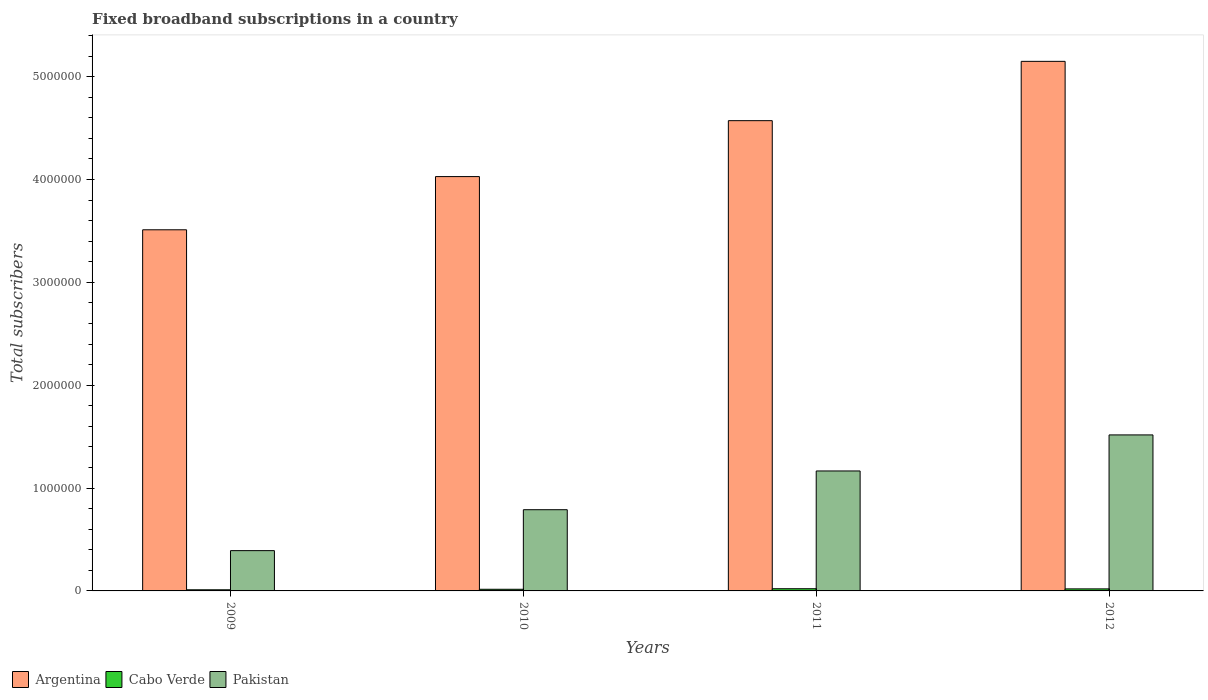In how many cases, is the number of bars for a given year not equal to the number of legend labels?
Offer a very short reply. 0. What is the number of broadband subscriptions in Pakistan in 2010?
Your answer should be compact. 7.89e+05. Across all years, what is the maximum number of broadband subscriptions in Pakistan?
Provide a succinct answer. 1.52e+06. Across all years, what is the minimum number of broadband subscriptions in Cabo Verde?
Provide a short and direct response. 1.10e+04. What is the total number of broadband subscriptions in Pakistan in the graph?
Ensure brevity in your answer.  3.86e+06. What is the difference between the number of broadband subscriptions in Cabo Verde in 2009 and that in 2012?
Keep it short and to the point. -8881. What is the difference between the number of broadband subscriptions in Argentina in 2010 and the number of broadband subscriptions in Pakistan in 2012?
Make the answer very short. 2.51e+06. What is the average number of broadband subscriptions in Pakistan per year?
Your response must be concise. 9.66e+05. In the year 2009, what is the difference between the number of broadband subscriptions in Argentina and number of broadband subscriptions in Pakistan?
Your answer should be very brief. 3.12e+06. What is the ratio of the number of broadband subscriptions in Cabo Verde in 2009 to that in 2010?
Give a very brief answer. 0.68. Is the number of broadband subscriptions in Argentina in 2009 less than that in 2012?
Ensure brevity in your answer.  Yes. What is the difference between the highest and the second highest number of broadband subscriptions in Argentina?
Your response must be concise. 5.77e+05. What is the difference between the highest and the lowest number of broadband subscriptions in Pakistan?
Ensure brevity in your answer.  1.13e+06. Is the sum of the number of broadband subscriptions in Argentina in 2011 and 2012 greater than the maximum number of broadband subscriptions in Cabo Verde across all years?
Keep it short and to the point. Yes. What does the 1st bar from the right in 2009 represents?
Make the answer very short. Pakistan. Are all the bars in the graph horizontal?
Keep it short and to the point. No. How many years are there in the graph?
Provide a succinct answer. 4. What is the difference between two consecutive major ticks on the Y-axis?
Ensure brevity in your answer.  1.00e+06. Does the graph contain any zero values?
Provide a short and direct response. No. Where does the legend appear in the graph?
Offer a very short reply. Bottom left. How many legend labels are there?
Make the answer very short. 3. How are the legend labels stacked?
Provide a succinct answer. Horizontal. What is the title of the graph?
Keep it short and to the point. Fixed broadband subscriptions in a country. What is the label or title of the X-axis?
Your answer should be compact. Years. What is the label or title of the Y-axis?
Ensure brevity in your answer.  Total subscribers. What is the Total subscribers in Argentina in 2009?
Provide a succinct answer. 3.51e+06. What is the Total subscribers of Cabo Verde in 2009?
Your answer should be compact. 1.10e+04. What is the Total subscribers in Pakistan in 2009?
Keep it short and to the point. 3.92e+05. What is the Total subscribers of Argentina in 2010?
Ensure brevity in your answer.  4.03e+06. What is the Total subscribers in Cabo Verde in 2010?
Keep it short and to the point. 1.61e+04. What is the Total subscribers in Pakistan in 2010?
Give a very brief answer. 7.89e+05. What is the Total subscribers of Argentina in 2011?
Make the answer very short. 4.57e+06. What is the Total subscribers in Cabo Verde in 2011?
Offer a terse response. 2.13e+04. What is the Total subscribers of Pakistan in 2011?
Ensure brevity in your answer.  1.17e+06. What is the Total subscribers of Argentina in 2012?
Offer a very short reply. 5.15e+06. What is the Total subscribers of Cabo Verde in 2012?
Give a very brief answer. 1.99e+04. What is the Total subscribers in Pakistan in 2012?
Make the answer very short. 1.52e+06. Across all years, what is the maximum Total subscribers of Argentina?
Keep it short and to the point. 5.15e+06. Across all years, what is the maximum Total subscribers of Cabo Verde?
Provide a succinct answer. 2.13e+04. Across all years, what is the maximum Total subscribers in Pakistan?
Make the answer very short. 1.52e+06. Across all years, what is the minimum Total subscribers of Argentina?
Your response must be concise. 3.51e+06. Across all years, what is the minimum Total subscribers in Cabo Verde?
Give a very brief answer. 1.10e+04. Across all years, what is the minimum Total subscribers in Pakistan?
Make the answer very short. 3.92e+05. What is the total Total subscribers of Argentina in the graph?
Your answer should be very brief. 1.73e+07. What is the total Total subscribers in Cabo Verde in the graph?
Your answer should be very brief. 6.82e+04. What is the total Total subscribers of Pakistan in the graph?
Provide a short and direct response. 3.86e+06. What is the difference between the Total subscribers of Argentina in 2009 and that in 2010?
Provide a short and direct response. -5.17e+05. What is the difference between the Total subscribers in Cabo Verde in 2009 and that in 2010?
Give a very brief answer. -5099. What is the difference between the Total subscribers in Pakistan in 2009 and that in 2010?
Your response must be concise. -3.98e+05. What is the difference between the Total subscribers of Argentina in 2009 and that in 2011?
Provide a succinct answer. -1.06e+06. What is the difference between the Total subscribers in Cabo Verde in 2009 and that in 2011?
Keep it short and to the point. -1.04e+04. What is the difference between the Total subscribers of Pakistan in 2009 and that in 2011?
Provide a succinct answer. -7.75e+05. What is the difference between the Total subscribers in Argentina in 2009 and that in 2012?
Ensure brevity in your answer.  -1.64e+06. What is the difference between the Total subscribers of Cabo Verde in 2009 and that in 2012?
Make the answer very short. -8881. What is the difference between the Total subscribers of Pakistan in 2009 and that in 2012?
Give a very brief answer. -1.13e+06. What is the difference between the Total subscribers in Argentina in 2010 and that in 2011?
Give a very brief answer. -5.44e+05. What is the difference between the Total subscribers of Cabo Verde in 2010 and that in 2011?
Make the answer very short. -5261. What is the difference between the Total subscribers of Pakistan in 2010 and that in 2011?
Offer a terse response. -3.77e+05. What is the difference between the Total subscribers in Argentina in 2010 and that in 2012?
Provide a succinct answer. -1.12e+06. What is the difference between the Total subscribers in Cabo Verde in 2010 and that in 2012?
Provide a succinct answer. -3782. What is the difference between the Total subscribers in Pakistan in 2010 and that in 2012?
Your response must be concise. -7.27e+05. What is the difference between the Total subscribers of Argentina in 2011 and that in 2012?
Keep it short and to the point. -5.77e+05. What is the difference between the Total subscribers of Cabo Verde in 2011 and that in 2012?
Offer a very short reply. 1479. What is the difference between the Total subscribers in Pakistan in 2011 and that in 2012?
Your answer should be very brief. -3.51e+05. What is the difference between the Total subscribers in Argentina in 2009 and the Total subscribers in Cabo Verde in 2010?
Provide a short and direct response. 3.49e+06. What is the difference between the Total subscribers of Argentina in 2009 and the Total subscribers of Pakistan in 2010?
Your response must be concise. 2.72e+06. What is the difference between the Total subscribers of Cabo Verde in 2009 and the Total subscribers of Pakistan in 2010?
Your response must be concise. -7.79e+05. What is the difference between the Total subscribers of Argentina in 2009 and the Total subscribers of Cabo Verde in 2011?
Ensure brevity in your answer.  3.49e+06. What is the difference between the Total subscribers in Argentina in 2009 and the Total subscribers in Pakistan in 2011?
Your answer should be compact. 2.34e+06. What is the difference between the Total subscribers in Cabo Verde in 2009 and the Total subscribers in Pakistan in 2011?
Offer a terse response. -1.16e+06. What is the difference between the Total subscribers in Argentina in 2009 and the Total subscribers in Cabo Verde in 2012?
Offer a terse response. 3.49e+06. What is the difference between the Total subscribers of Argentina in 2009 and the Total subscribers of Pakistan in 2012?
Provide a succinct answer. 1.99e+06. What is the difference between the Total subscribers of Cabo Verde in 2009 and the Total subscribers of Pakistan in 2012?
Make the answer very short. -1.51e+06. What is the difference between the Total subscribers of Argentina in 2010 and the Total subscribers of Cabo Verde in 2011?
Give a very brief answer. 4.01e+06. What is the difference between the Total subscribers of Argentina in 2010 and the Total subscribers of Pakistan in 2011?
Your response must be concise. 2.86e+06. What is the difference between the Total subscribers of Cabo Verde in 2010 and the Total subscribers of Pakistan in 2011?
Make the answer very short. -1.15e+06. What is the difference between the Total subscribers of Argentina in 2010 and the Total subscribers of Cabo Verde in 2012?
Offer a very short reply. 4.01e+06. What is the difference between the Total subscribers of Argentina in 2010 and the Total subscribers of Pakistan in 2012?
Offer a terse response. 2.51e+06. What is the difference between the Total subscribers in Cabo Verde in 2010 and the Total subscribers in Pakistan in 2012?
Your answer should be compact. -1.50e+06. What is the difference between the Total subscribers of Argentina in 2011 and the Total subscribers of Cabo Verde in 2012?
Keep it short and to the point. 4.55e+06. What is the difference between the Total subscribers in Argentina in 2011 and the Total subscribers in Pakistan in 2012?
Make the answer very short. 3.06e+06. What is the difference between the Total subscribers of Cabo Verde in 2011 and the Total subscribers of Pakistan in 2012?
Ensure brevity in your answer.  -1.50e+06. What is the average Total subscribers of Argentina per year?
Your answer should be compact. 4.31e+06. What is the average Total subscribers in Cabo Verde per year?
Make the answer very short. 1.71e+04. What is the average Total subscribers of Pakistan per year?
Your answer should be compact. 9.66e+05. In the year 2009, what is the difference between the Total subscribers of Argentina and Total subscribers of Cabo Verde?
Provide a short and direct response. 3.50e+06. In the year 2009, what is the difference between the Total subscribers of Argentina and Total subscribers of Pakistan?
Your answer should be very brief. 3.12e+06. In the year 2009, what is the difference between the Total subscribers of Cabo Verde and Total subscribers of Pakistan?
Your answer should be compact. -3.81e+05. In the year 2010, what is the difference between the Total subscribers of Argentina and Total subscribers of Cabo Verde?
Offer a terse response. 4.01e+06. In the year 2010, what is the difference between the Total subscribers in Argentina and Total subscribers in Pakistan?
Make the answer very short. 3.24e+06. In the year 2010, what is the difference between the Total subscribers of Cabo Verde and Total subscribers of Pakistan?
Give a very brief answer. -7.73e+05. In the year 2011, what is the difference between the Total subscribers in Argentina and Total subscribers in Cabo Verde?
Your response must be concise. 4.55e+06. In the year 2011, what is the difference between the Total subscribers of Argentina and Total subscribers of Pakistan?
Give a very brief answer. 3.41e+06. In the year 2011, what is the difference between the Total subscribers of Cabo Verde and Total subscribers of Pakistan?
Provide a succinct answer. -1.14e+06. In the year 2012, what is the difference between the Total subscribers of Argentina and Total subscribers of Cabo Verde?
Give a very brief answer. 5.13e+06. In the year 2012, what is the difference between the Total subscribers in Argentina and Total subscribers in Pakistan?
Ensure brevity in your answer.  3.63e+06. In the year 2012, what is the difference between the Total subscribers of Cabo Verde and Total subscribers of Pakistan?
Make the answer very short. -1.50e+06. What is the ratio of the Total subscribers in Argentina in 2009 to that in 2010?
Offer a terse response. 0.87. What is the ratio of the Total subscribers in Cabo Verde in 2009 to that in 2010?
Keep it short and to the point. 0.68. What is the ratio of the Total subscribers in Pakistan in 2009 to that in 2010?
Ensure brevity in your answer.  0.5. What is the ratio of the Total subscribers in Argentina in 2009 to that in 2011?
Keep it short and to the point. 0.77. What is the ratio of the Total subscribers of Cabo Verde in 2009 to that in 2011?
Your answer should be very brief. 0.51. What is the ratio of the Total subscribers in Pakistan in 2009 to that in 2011?
Make the answer very short. 0.34. What is the ratio of the Total subscribers of Argentina in 2009 to that in 2012?
Ensure brevity in your answer.  0.68. What is the ratio of the Total subscribers of Cabo Verde in 2009 to that in 2012?
Ensure brevity in your answer.  0.55. What is the ratio of the Total subscribers of Pakistan in 2009 to that in 2012?
Make the answer very short. 0.26. What is the ratio of the Total subscribers of Argentina in 2010 to that in 2011?
Make the answer very short. 0.88. What is the ratio of the Total subscribers in Cabo Verde in 2010 to that in 2011?
Your response must be concise. 0.75. What is the ratio of the Total subscribers in Pakistan in 2010 to that in 2011?
Ensure brevity in your answer.  0.68. What is the ratio of the Total subscribers in Argentina in 2010 to that in 2012?
Make the answer very short. 0.78. What is the ratio of the Total subscribers of Cabo Verde in 2010 to that in 2012?
Offer a terse response. 0.81. What is the ratio of the Total subscribers of Pakistan in 2010 to that in 2012?
Provide a succinct answer. 0.52. What is the ratio of the Total subscribers of Argentina in 2011 to that in 2012?
Provide a short and direct response. 0.89. What is the ratio of the Total subscribers in Cabo Verde in 2011 to that in 2012?
Keep it short and to the point. 1.07. What is the ratio of the Total subscribers of Pakistan in 2011 to that in 2012?
Offer a very short reply. 0.77. What is the difference between the highest and the second highest Total subscribers in Argentina?
Keep it short and to the point. 5.77e+05. What is the difference between the highest and the second highest Total subscribers in Cabo Verde?
Provide a succinct answer. 1479. What is the difference between the highest and the second highest Total subscribers in Pakistan?
Keep it short and to the point. 3.51e+05. What is the difference between the highest and the lowest Total subscribers in Argentina?
Your answer should be very brief. 1.64e+06. What is the difference between the highest and the lowest Total subscribers in Cabo Verde?
Your answer should be very brief. 1.04e+04. What is the difference between the highest and the lowest Total subscribers in Pakistan?
Offer a terse response. 1.13e+06. 